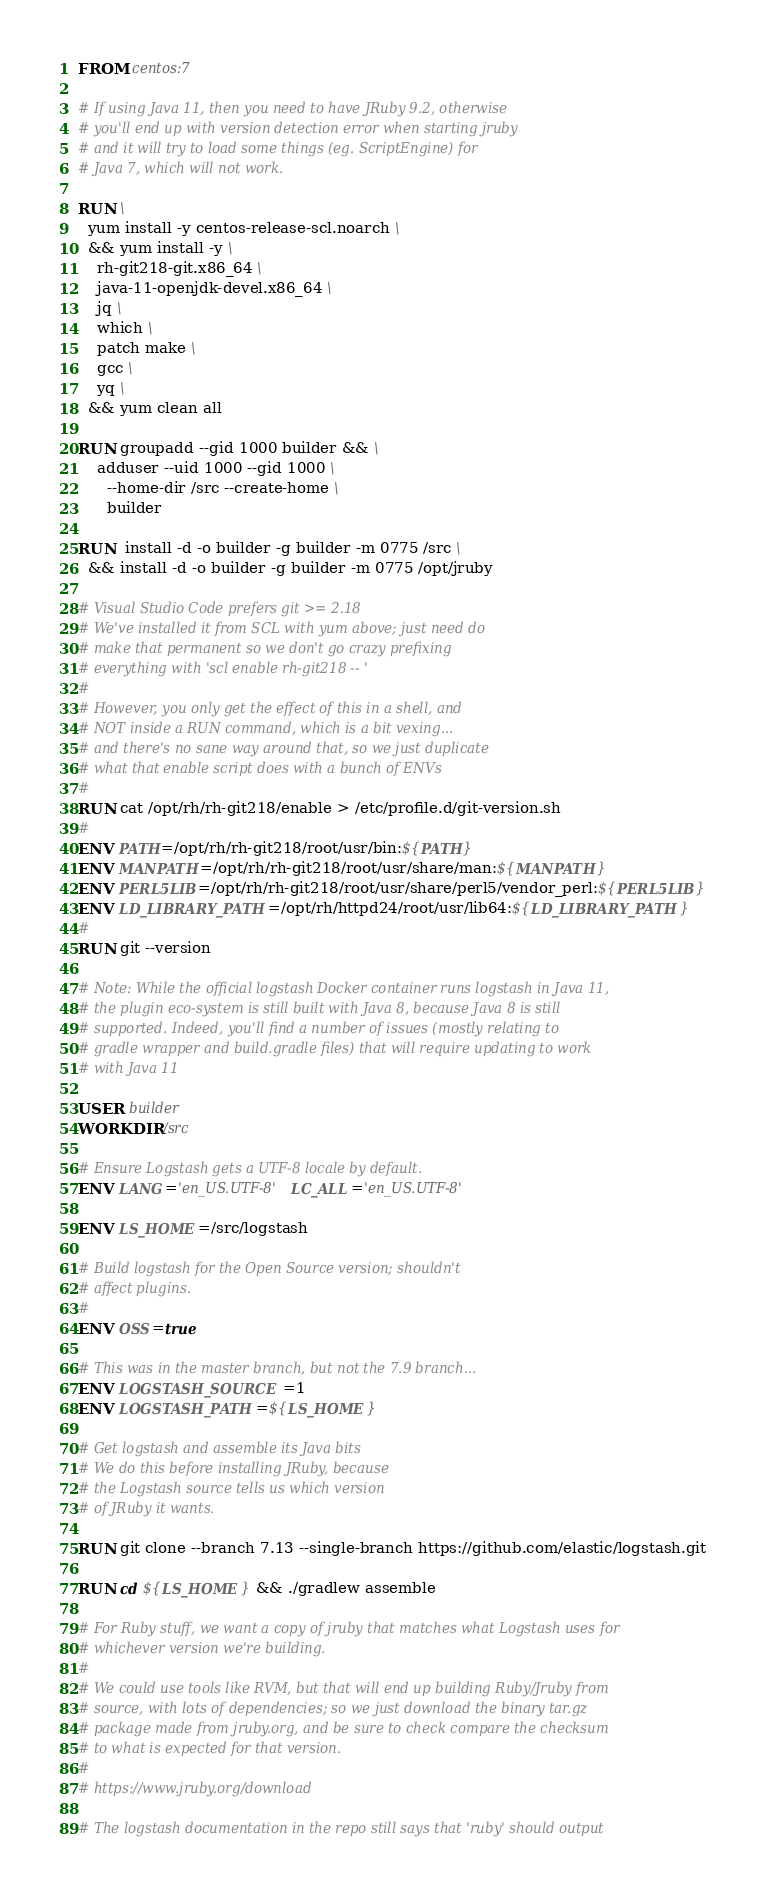<code> <loc_0><loc_0><loc_500><loc_500><_Dockerfile_>FROM centos:7

# If using Java 11, then you need to have JRuby 9.2, otherwise
# you'll end up with version detection error when starting jruby
# and it will try to load some things (eg. ScriptEngine) for
# Java 7, which will not work.

RUN \
  yum install -y centos-release-scl.noarch \
  && yum install -y \
    rh-git218-git.x86_64 \
    java-11-openjdk-devel.x86_64 \
    jq \
    which \
    patch make \
    gcc \
    yq \
  && yum clean all

RUN groupadd --gid 1000 builder && \
    adduser --uid 1000 --gid 1000 \
      --home-dir /src --create-home \
      builder

RUN  install -d -o builder -g builder -m 0775 /src \
  && install -d -o builder -g builder -m 0775 /opt/jruby

# Visual Studio Code prefers git >= 2.18
# We've installed it from SCL with yum above; just need do
# make that permanent so we don't go crazy prefixing
# everything with 'scl enable rh-git218 -- '
#
# However, you only get the effect of this in a shell, and
# NOT inside a RUN command, which is a bit vexing...
# and there's no sane way around that, so we just duplicate
# what that enable script does with a bunch of ENVs
#
RUN cat /opt/rh/rh-git218/enable > /etc/profile.d/git-version.sh
#
ENV PATH=/opt/rh/rh-git218/root/usr/bin:${PATH}
ENV MANPATH=/opt/rh/rh-git218/root/usr/share/man:${MANPATH}
ENV PERL5LIB=/opt/rh/rh-git218/root/usr/share/perl5/vendor_perl:${PERL5LIB}
ENV LD_LIBRARY_PATH=/opt/rh/httpd24/root/usr/lib64:${LD_LIBRARY_PATH}
#
RUN git --version

# Note: While the official logstash Docker container runs logstash in Java 11,
# the plugin eco-system is still built with Java 8, because Java 8 is still
# supported. Indeed, you'll find a number of issues (mostly relating to
# gradle wrapper and build.gradle files) that will require updating to work
# with Java 11

USER builder
WORKDIR /src

# Ensure Logstash gets a UTF-8 locale by default.
ENV LANG='en_US.UTF-8' LC_ALL='en_US.UTF-8'

ENV LS_HOME=/src/logstash

# Build logstash for the Open Source version; shouldn't
# affect plugins.
#
ENV OSS=true

# This was in the master branch, but not the 7.9 branch...
ENV LOGSTASH_SOURCE=1
ENV LOGSTASH_PATH=${LS_HOME}

# Get logstash and assemble its Java bits
# We do this before installing JRuby, because
# the Logstash source tells us which version
# of JRuby it wants.

RUN git clone --branch 7.13 --single-branch https://github.com/elastic/logstash.git

RUN cd ${LS_HOME} && ./gradlew assemble

# For Ruby stuff, we want a copy of jruby that matches what Logstash uses for
# whichever version we're building.
#
# We could use tools like RVM, but that will end up building Ruby/Jruby from
# source, with lots of dependencies; so we just download the binary tar.gz
# package made from jruby.org, and be sure to check compare the checksum
# to what is expected for that version.
#
# https://www.jruby.org/download

# The logstash documentation in the repo still says that 'ruby' should output</code> 